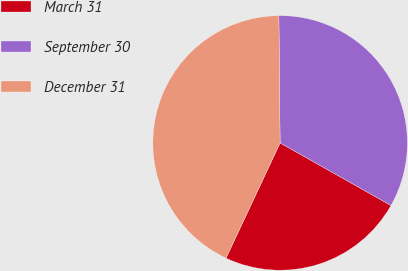Convert chart. <chart><loc_0><loc_0><loc_500><loc_500><pie_chart><fcel>March 31<fcel>September 30<fcel>December 31<nl><fcel>23.81%<fcel>33.33%<fcel>42.86%<nl></chart> 